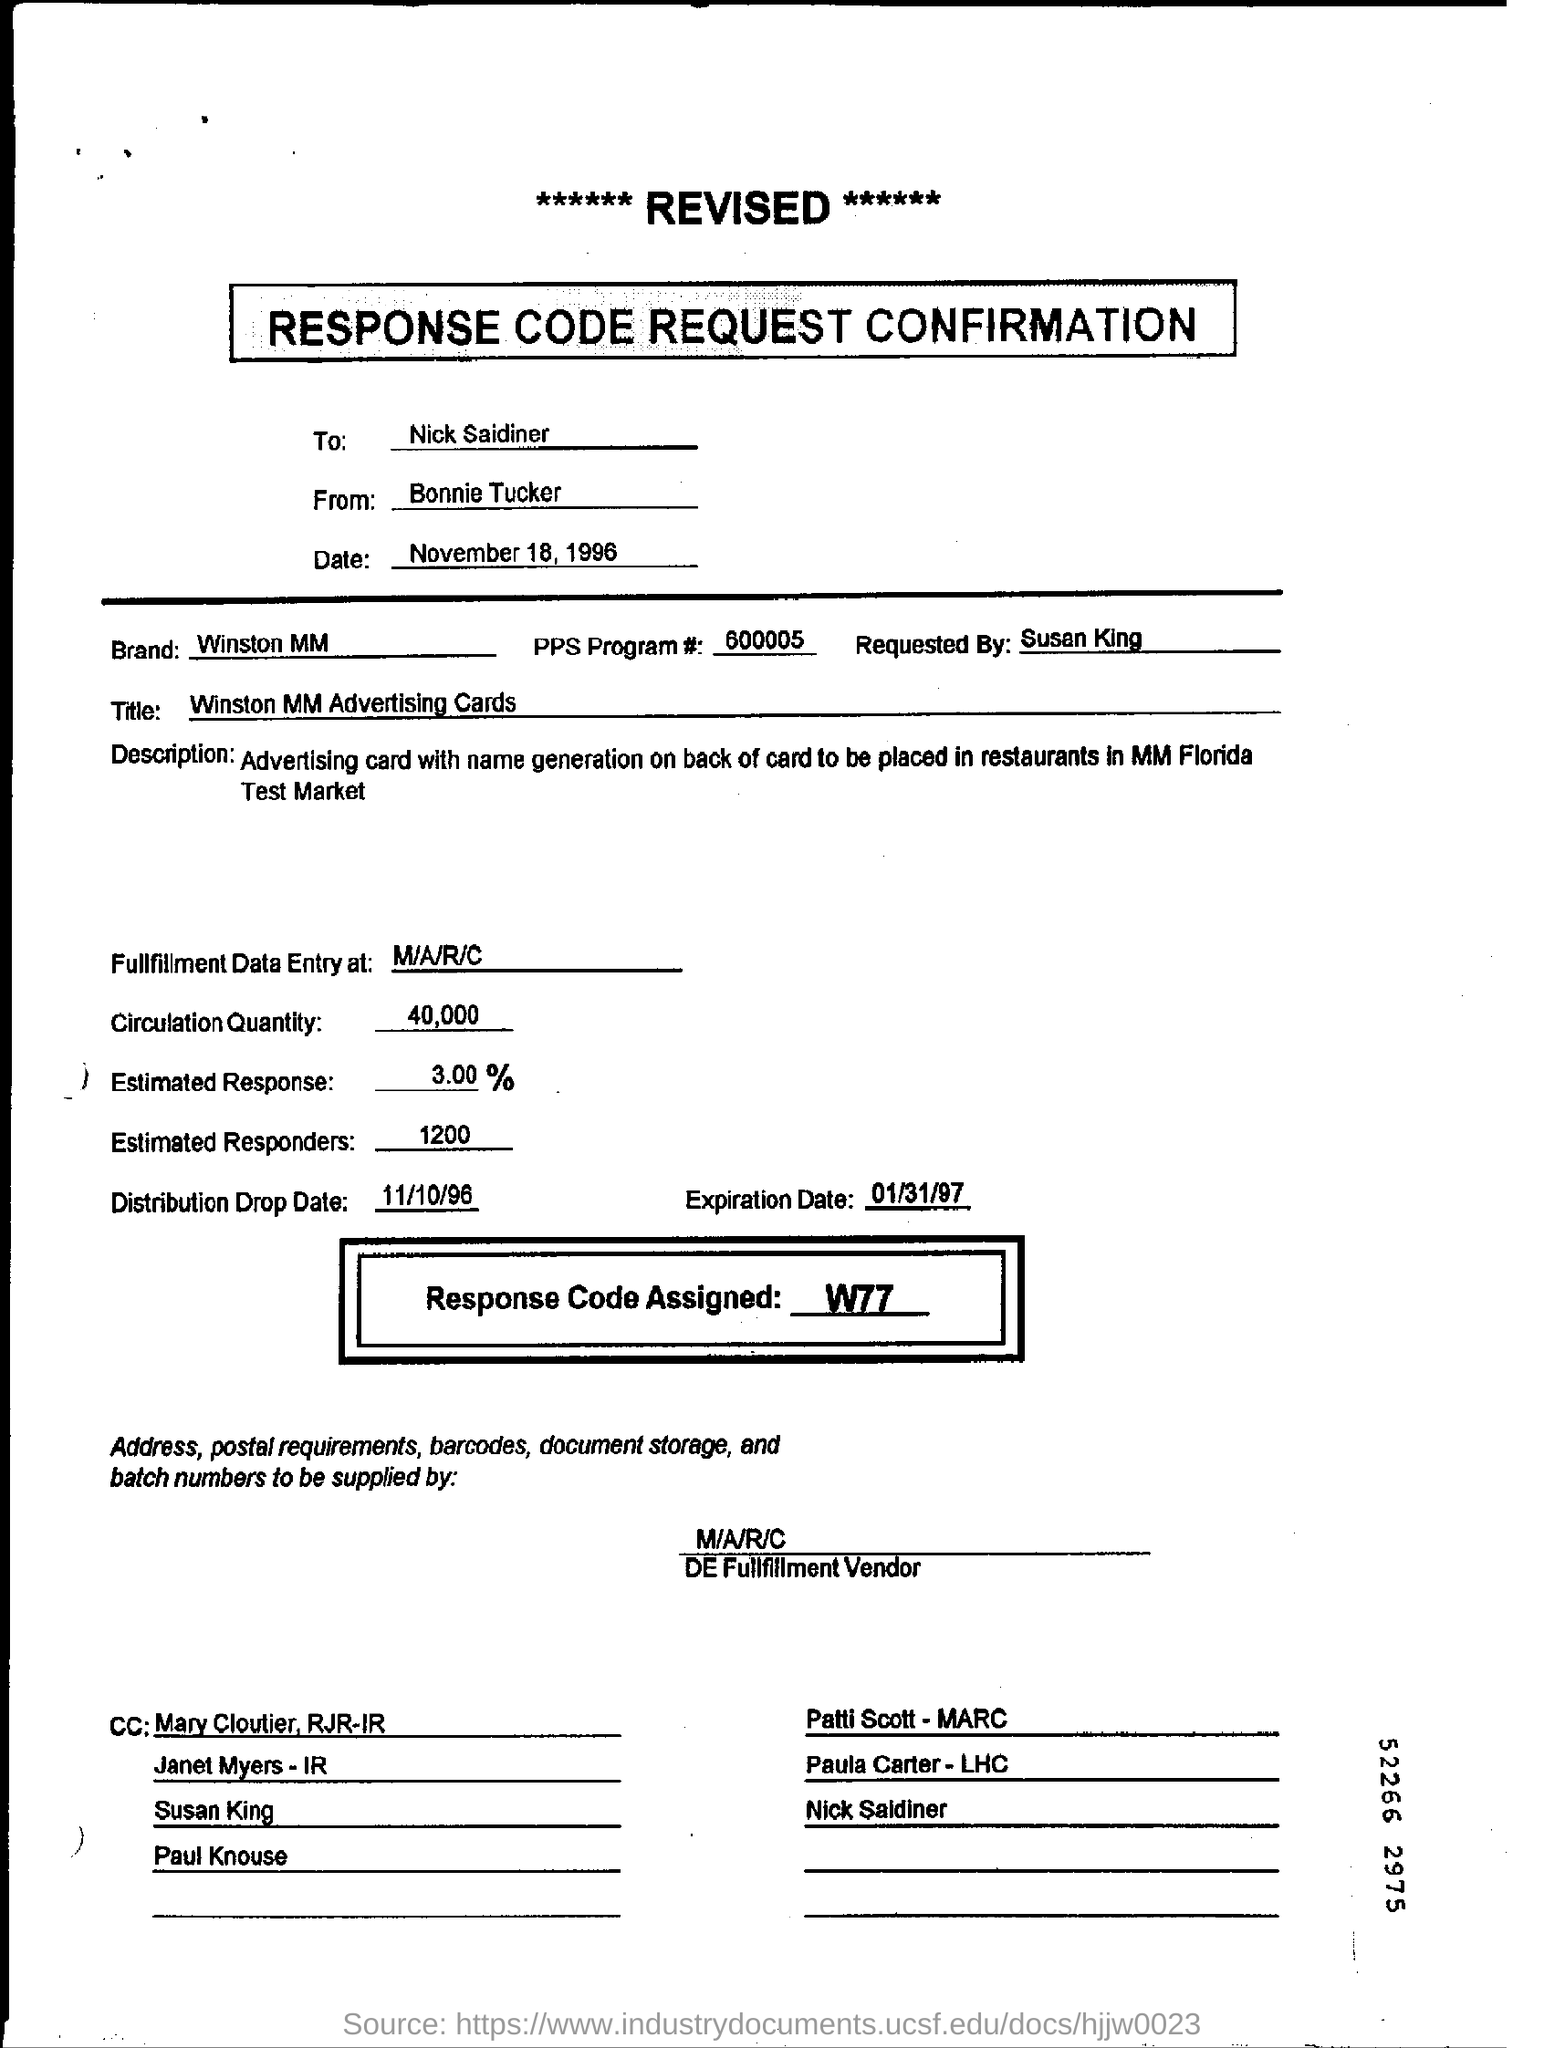Which response code is assigned ?
Provide a succinct answer. W77. To whom the confirmation is sent ?
Your answer should be compact. Nick Saidiner. What is the distribution drop date ?
Make the answer very short. 11/10/96. What is the Quantity of circulation ?
Offer a very short reply. 40,000. 